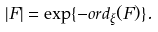<formula> <loc_0><loc_0><loc_500><loc_500>| F | = \exp \{ - o r d _ { \xi } ( F ) \} .</formula> 